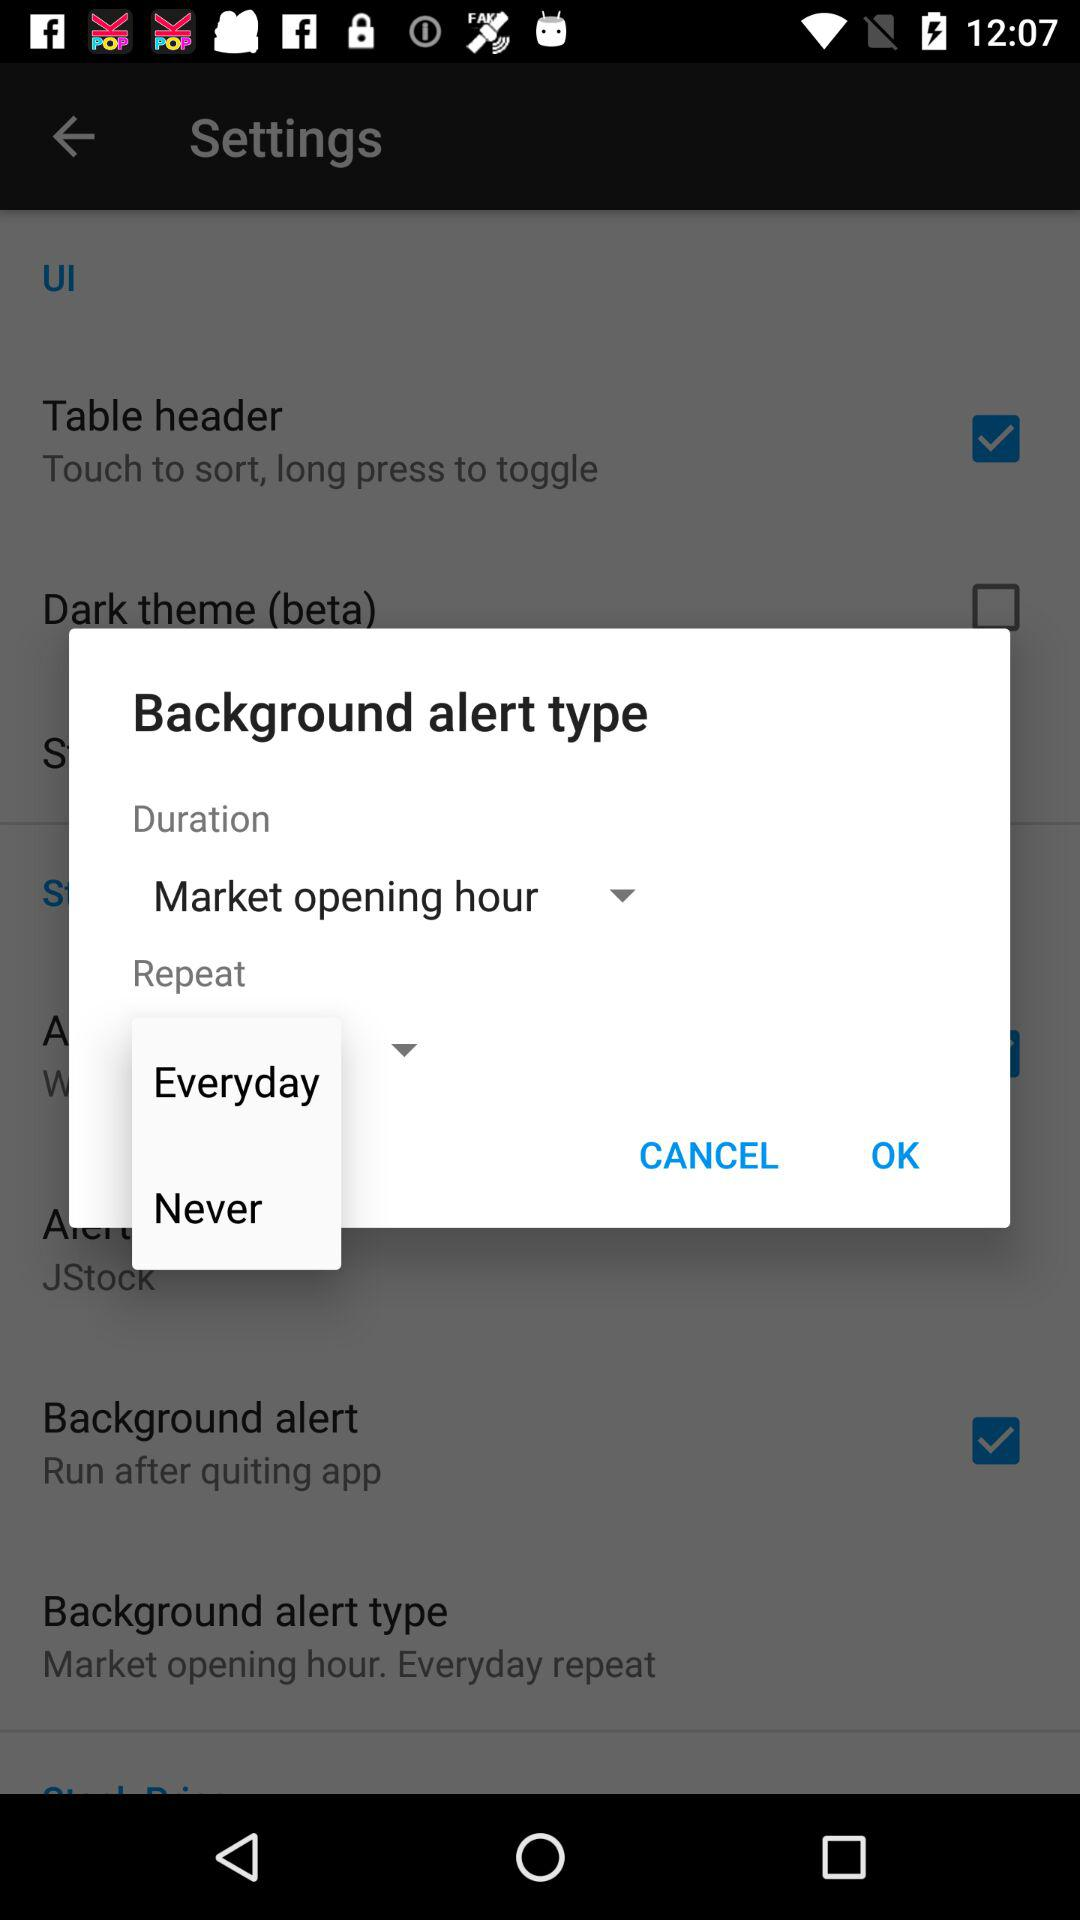What is the selected duration? The selected duration is "Market opening hour". 